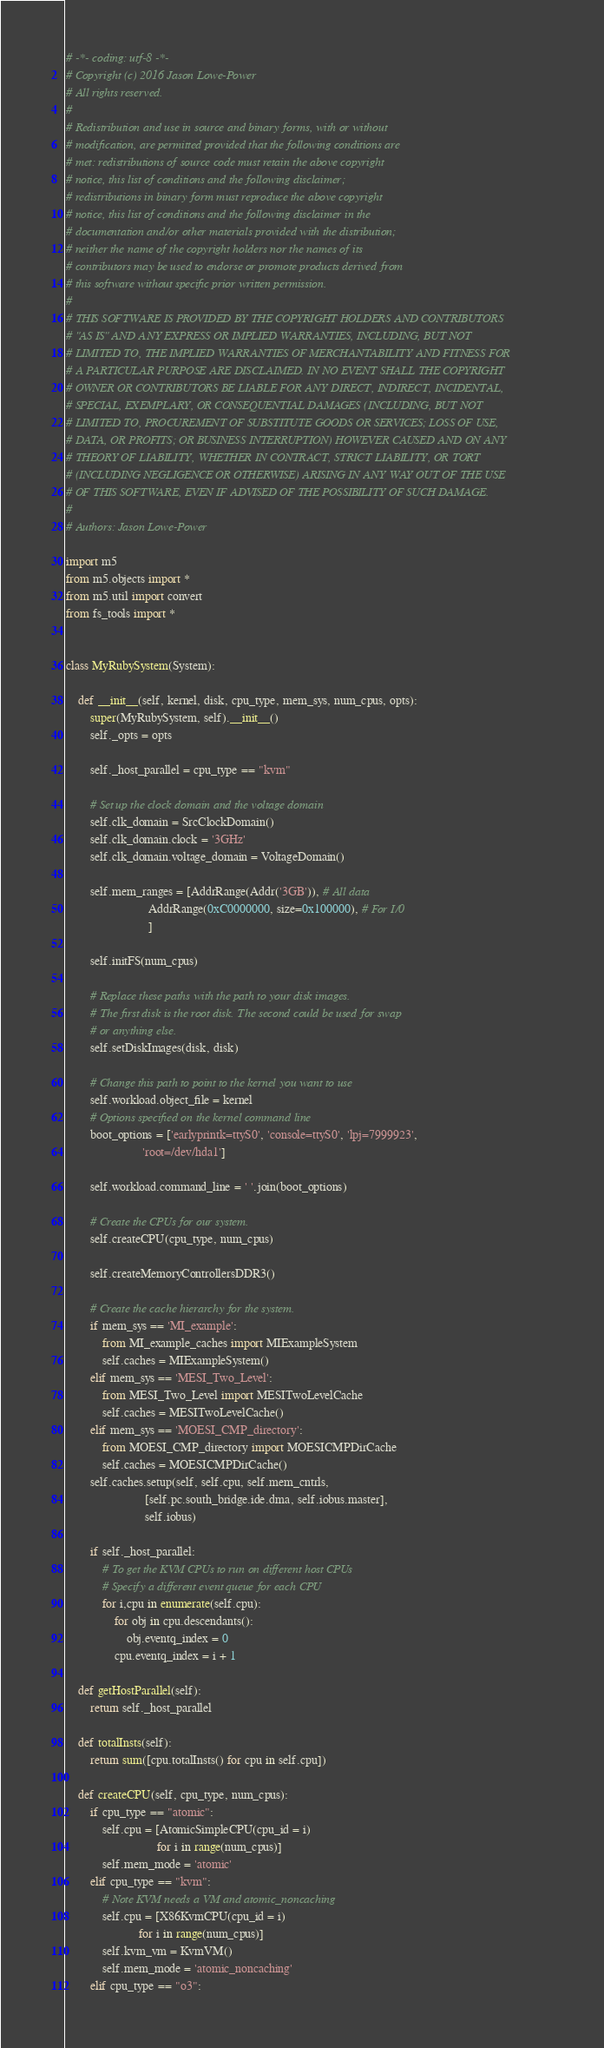Convert code to text. <code><loc_0><loc_0><loc_500><loc_500><_Python_># -*- coding: utf-8 -*-
# Copyright (c) 2016 Jason Lowe-Power
# All rights reserved.
#
# Redistribution and use in source and binary forms, with or without
# modification, are permitted provided that the following conditions are
# met: redistributions of source code must retain the above copyright
# notice, this list of conditions and the following disclaimer;
# redistributions in binary form must reproduce the above copyright
# notice, this list of conditions and the following disclaimer in the
# documentation and/or other materials provided with the distribution;
# neither the name of the copyright holders nor the names of its
# contributors may be used to endorse or promote products derived from
# this software without specific prior written permission.
#
# THIS SOFTWARE IS PROVIDED BY THE COPYRIGHT HOLDERS AND CONTRIBUTORS
# "AS IS" AND ANY EXPRESS OR IMPLIED WARRANTIES, INCLUDING, BUT NOT
# LIMITED TO, THE IMPLIED WARRANTIES OF MERCHANTABILITY AND FITNESS FOR
# A PARTICULAR PURPOSE ARE DISCLAIMED. IN NO EVENT SHALL THE COPYRIGHT
# OWNER OR CONTRIBUTORS BE LIABLE FOR ANY DIRECT, INDIRECT, INCIDENTAL,
# SPECIAL, EXEMPLARY, OR CONSEQUENTIAL DAMAGES (INCLUDING, BUT NOT
# LIMITED TO, PROCUREMENT OF SUBSTITUTE GOODS OR SERVICES; LOSS OF USE,
# DATA, OR PROFITS; OR BUSINESS INTERRUPTION) HOWEVER CAUSED AND ON ANY
# THEORY OF LIABILITY, WHETHER IN CONTRACT, STRICT LIABILITY, OR TORT
# (INCLUDING NEGLIGENCE OR OTHERWISE) ARISING IN ANY WAY OUT OF THE USE
# OF THIS SOFTWARE, EVEN IF ADVISED OF THE POSSIBILITY OF SUCH DAMAGE.
#
# Authors: Jason Lowe-Power

import m5
from m5.objects import *
from m5.util import convert
from fs_tools import *


class MyRubySystem(System):

    def __init__(self, kernel, disk, cpu_type, mem_sys, num_cpus, opts):
        super(MyRubySystem, self).__init__()
        self._opts = opts

        self._host_parallel = cpu_type == "kvm"

        # Set up the clock domain and the voltage domain
        self.clk_domain = SrcClockDomain()
        self.clk_domain.clock = '3GHz'
        self.clk_domain.voltage_domain = VoltageDomain()

        self.mem_ranges = [AddrRange(Addr('3GB')), # All data
                           AddrRange(0xC0000000, size=0x100000), # For I/0
                           ]

        self.initFS(num_cpus)

        # Replace these paths with the path to your disk images.
        # The first disk is the root disk. The second could be used for swap
        # or anything else.
        self.setDiskImages(disk, disk)

        # Change this path to point to the kernel you want to use
        self.workload.object_file = kernel
        # Options specified on the kernel command line
        boot_options = ['earlyprintk=ttyS0', 'console=ttyS0', 'lpj=7999923',
                         'root=/dev/hda1']

        self.workload.command_line = ' '.join(boot_options)

        # Create the CPUs for our system.
        self.createCPU(cpu_type, num_cpus)

        self.createMemoryControllersDDR3()

        # Create the cache hierarchy for the system.
        if mem_sys == 'MI_example':
            from MI_example_caches import MIExampleSystem
            self.caches = MIExampleSystem()
        elif mem_sys == 'MESI_Two_Level':
            from MESI_Two_Level import MESITwoLevelCache
            self.caches = MESITwoLevelCache()
        elif mem_sys == 'MOESI_CMP_directory':
            from MOESI_CMP_directory import MOESICMPDirCache
            self.caches = MOESICMPDirCache()
        self.caches.setup(self, self.cpu, self.mem_cntrls,
                          [self.pc.south_bridge.ide.dma, self.iobus.master],
                          self.iobus)

        if self._host_parallel:
            # To get the KVM CPUs to run on different host CPUs
            # Specify a different event queue for each CPU
            for i,cpu in enumerate(self.cpu):
                for obj in cpu.descendants():
                    obj.eventq_index = 0
                cpu.eventq_index = i + 1

    def getHostParallel(self):
        return self._host_parallel

    def totalInsts(self):
        return sum([cpu.totalInsts() for cpu in self.cpu])

    def createCPU(self, cpu_type, num_cpus):
        if cpu_type == "atomic":
            self.cpu = [AtomicSimpleCPU(cpu_id = i)
                              for i in range(num_cpus)]
            self.mem_mode = 'atomic'
        elif cpu_type == "kvm":
            # Note KVM needs a VM and atomic_noncaching
            self.cpu = [X86KvmCPU(cpu_id = i)
                        for i in range(num_cpus)]
            self.kvm_vm = KvmVM()
            self.mem_mode = 'atomic_noncaching'
        elif cpu_type == "o3":</code> 